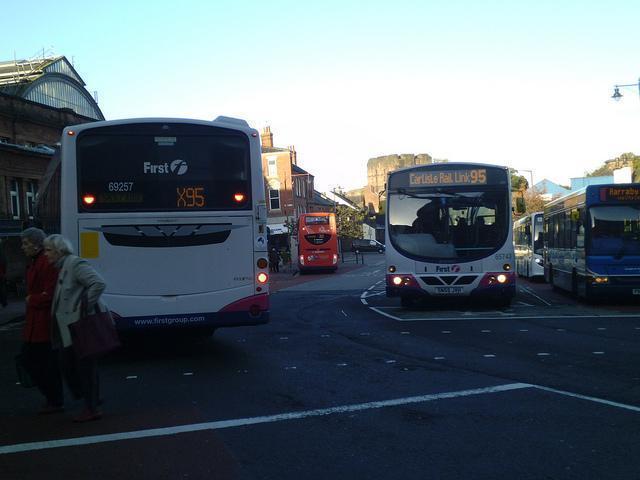In which area do these buses run?
Select the accurate response from the four choices given to answer the question.
Options: Tundra, desert, urban, rural. Urban. 